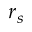Convert formula to latex. <formula><loc_0><loc_0><loc_500><loc_500>r _ { s }</formula> 